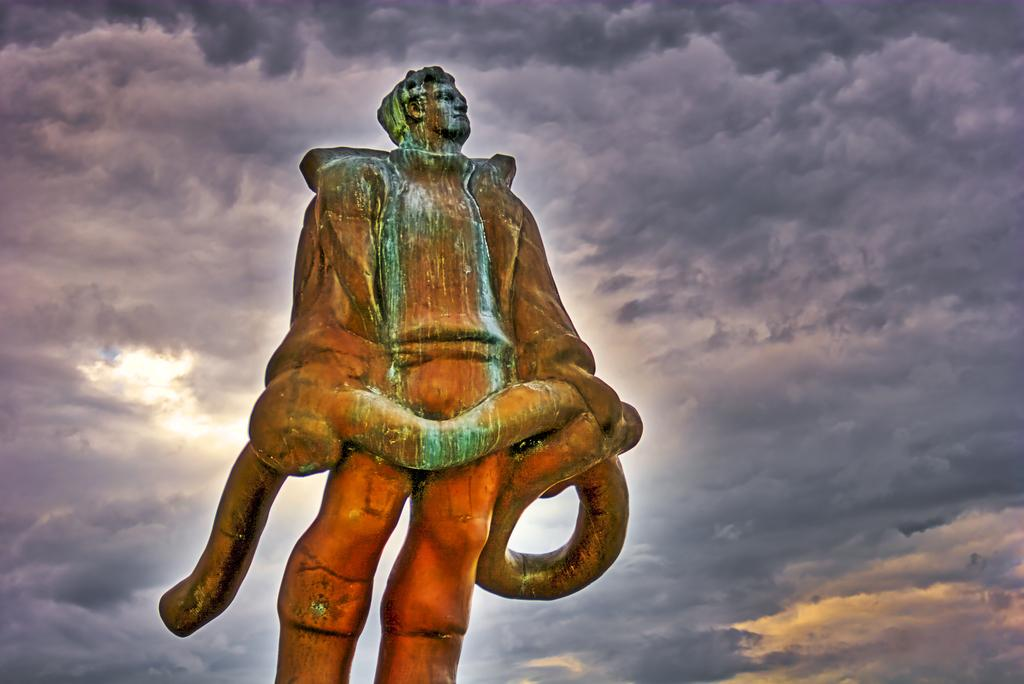What is the main subject of the image? There is a sculpture of a person standing in the image. Can you describe the sky in the image? The sky is cloudy in the image. What type of effect does the calculator have on the duck in the image? There is no calculator or duck present in the image, so no such effect can be observed. 